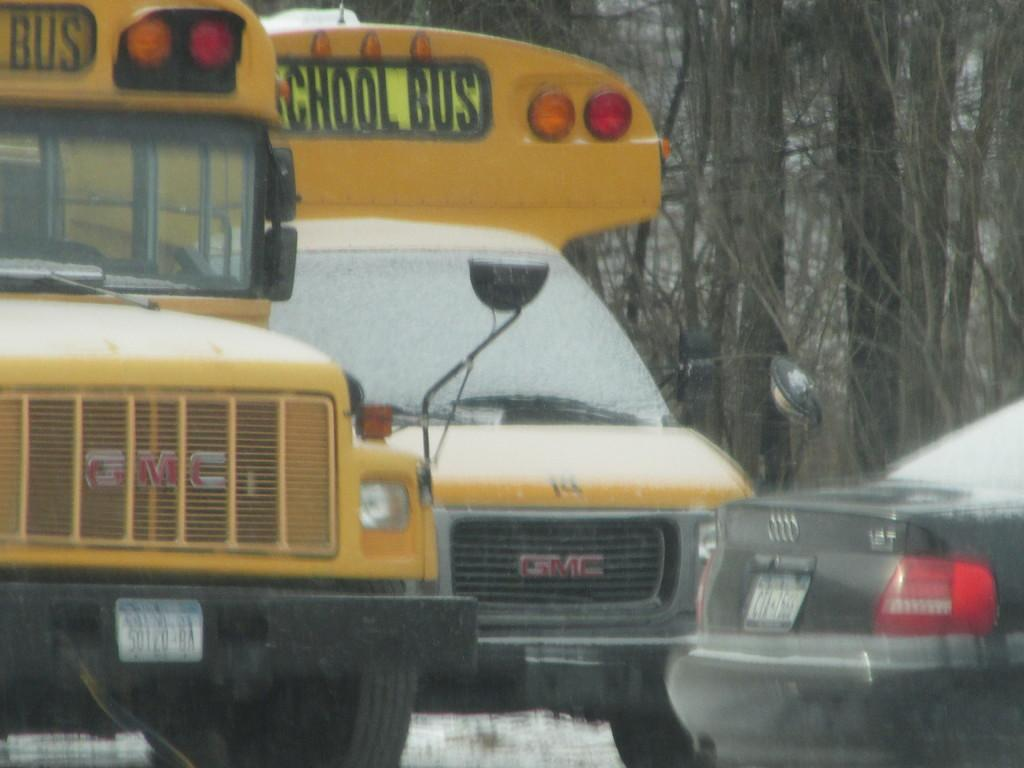How many vehicles are present in the image? There are three vehicles in the image. What can be seen behind the vehicles in the image? There are trees behind the vehicles in the image. What type of soda is being advertised on the side of the vehicles in the image? There is no soda or advertisement present on the vehicles in the image. How many geese are standing next to the vehicles in the image? There are no geese present in the image. 